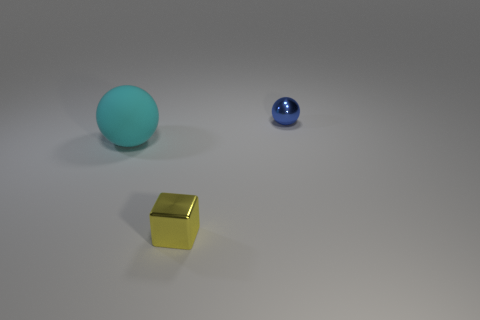Subtract all cyan balls. How many balls are left? 1 Subtract all blue metallic objects. Subtract all brown rubber objects. How many objects are left? 2 Add 1 rubber balls. How many rubber balls are left? 2 Add 1 small gray rubber blocks. How many small gray rubber blocks exist? 1 Add 1 tiny purple shiny cylinders. How many objects exist? 4 Subtract 1 yellow blocks. How many objects are left? 2 Subtract all blocks. How many objects are left? 2 Subtract all red spheres. Subtract all brown cubes. How many spheres are left? 2 Subtract all green cylinders. How many green blocks are left? 0 